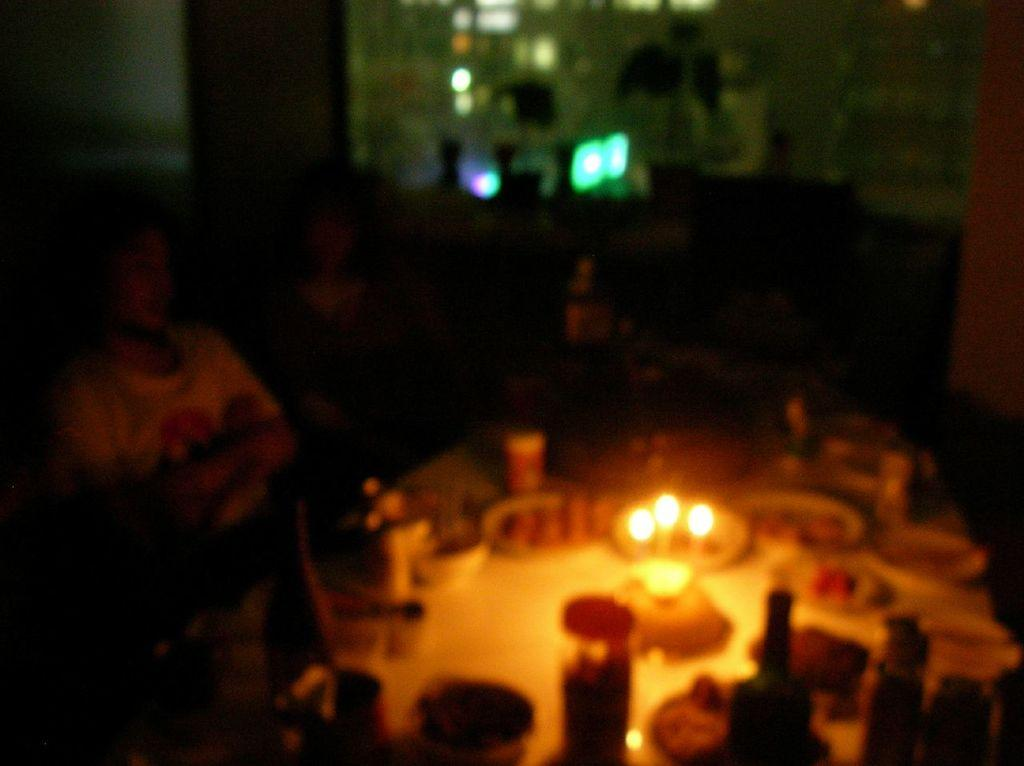What are the people in the image doing? The people in the image are seated. What type of food can be seen in the image? There is food in bowls in the image. What type of containers are visible in the image? There are glasses and bottles in the image. What additional items can be seen on the table in the image? There are candles on the table in the image. How would you describe the lighting conditions in the image? The image was taken in a dark environment. What type of grape is being used to paint the roof in the image? There is no grape or painting activity present in the image. What type of brush is being used to apply the paint to the roof in the image? There is no brush or painting activity present in the image. 